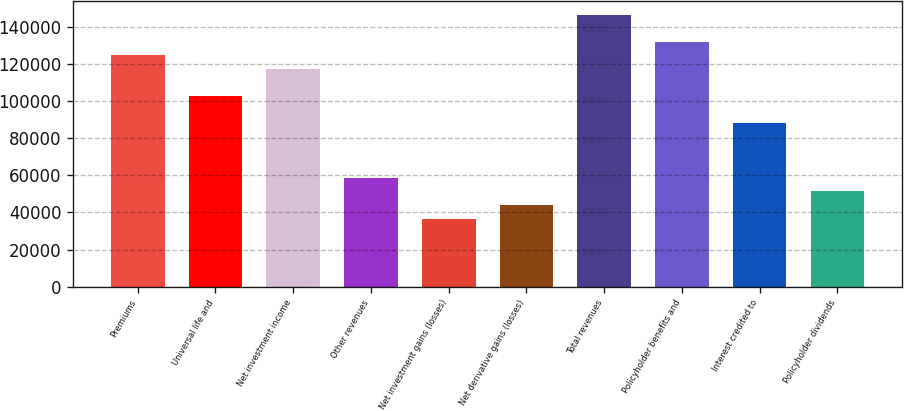<chart> <loc_0><loc_0><loc_500><loc_500><bar_chart><fcel>Premiums<fcel>Universal life and<fcel>Net investment income<fcel>Other revenues<fcel>Net investment gains (losses)<fcel>Net derivative gains (losses)<fcel>Total revenues<fcel>Policyholder benefits and<fcel>Interest credited to<fcel>Policyholder dividends<nl><fcel>124636<fcel>102642<fcel>117305<fcel>58653.1<fcel>36658.7<fcel>43990.2<fcel>146631<fcel>131968<fcel>87979<fcel>51321.6<nl></chart> 